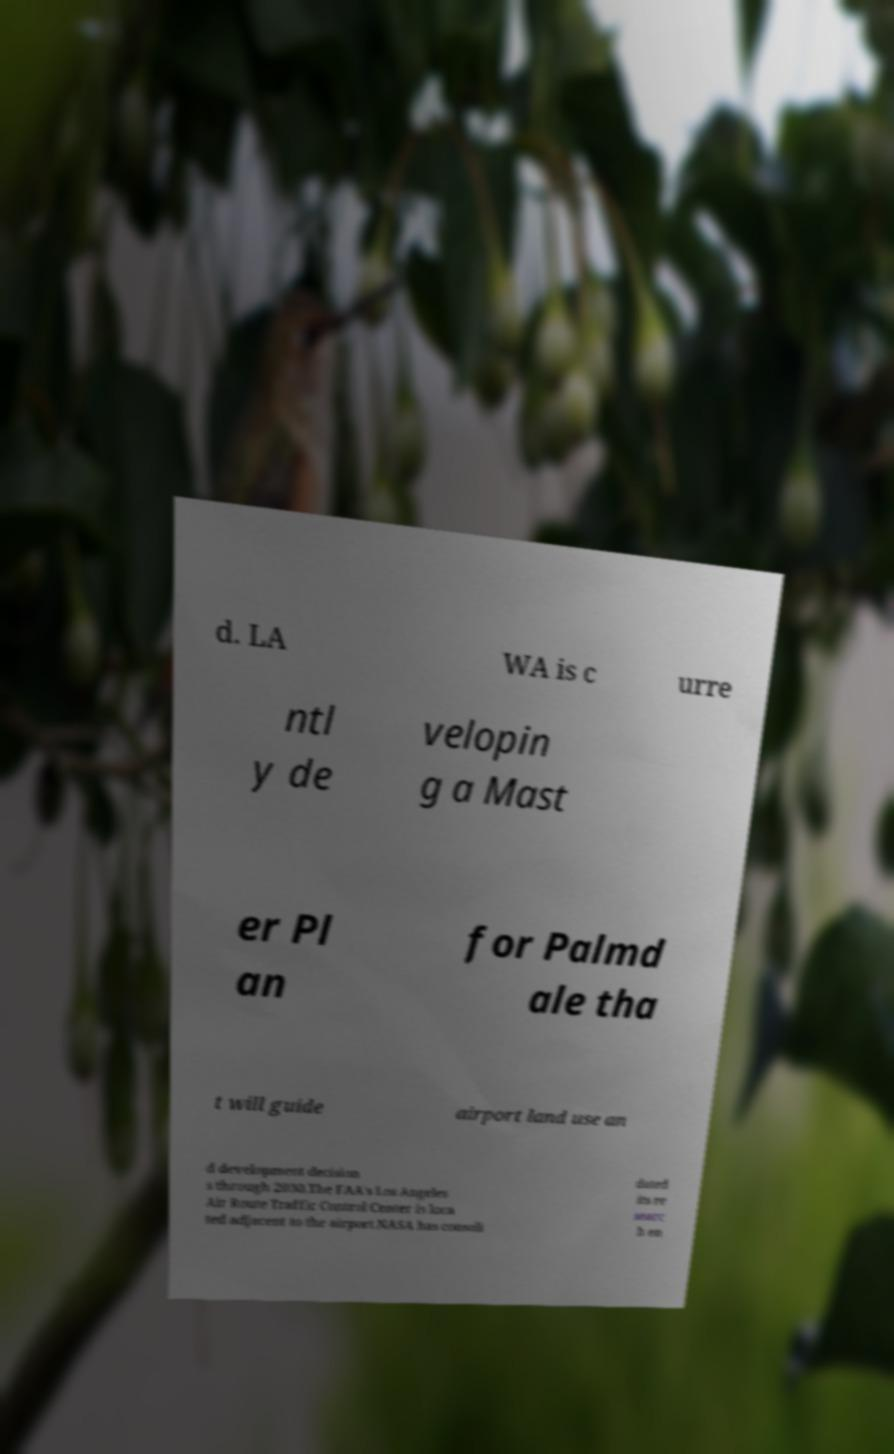I need the written content from this picture converted into text. Can you do that? d. LA WA is c urre ntl y de velopin g a Mast er Pl an for Palmd ale tha t will guide airport land use an d development decision s through 2030.The FAA's Los Angeles Air Route Traffic Control Center is loca ted adjacent to the airport.NASA has consoli dated its re searc h en 